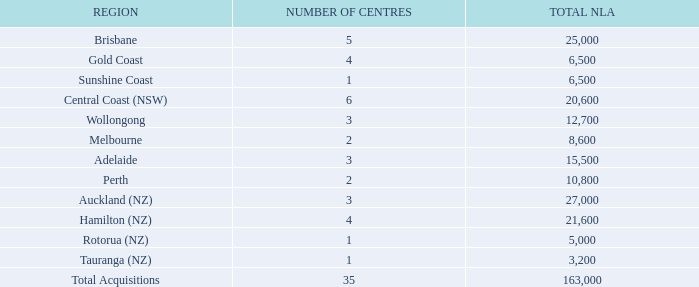ACQUISITIONS National Storage has successfully transacted 35 acquisitions and 4 development sites in FY19 and continues to pursue high-quality acquisitions across Australia and New Zealand. The ability to acquire and integrate strategic accretive acquisitions is one of National Storage’s major competitive advantages and a cornerstone of its growth strategy. This active growth strategy also strengthens and scales the National Storage operating platform which drives efficiencies across the business.
WINE ARK Wine Ark, Australia’s largest wine storage provider is part of the National Storage group and houses over two million bottles of fine wine across 15 centres for clients located in over 30 countries. There are few businesses in Australia with more experience when it comes to storing and managing premium wine. Throughout FY19 Wine Ark continued to strengthen its relationship and involvement in the greater wine trade supporting the Wine Communicators of Australia, Sommeliers Association of Australia, Wine Australia and Commanderie de Bordeaux (Australian Chapter).
What was the total NLA in Brisbane? 25,000. What was the total number of acquisitions in FY19? 35 acquisitions. What are the benefits of active growth strategy? Strengthens and scales the national storage operating platform which drives efficiencies across the business. What is the sum of centres in Brisbane and Gold Coast? 5 + 4
Answer: 9. What is the difference in the NLA between Sunshine Cost and Brisbane? 25,000 - 6,500
Answer: 18500. What is the average total NLA of Sunshine Coast and Gold Coast? (6,500 + 6,500) / 2
Answer: 6500. 